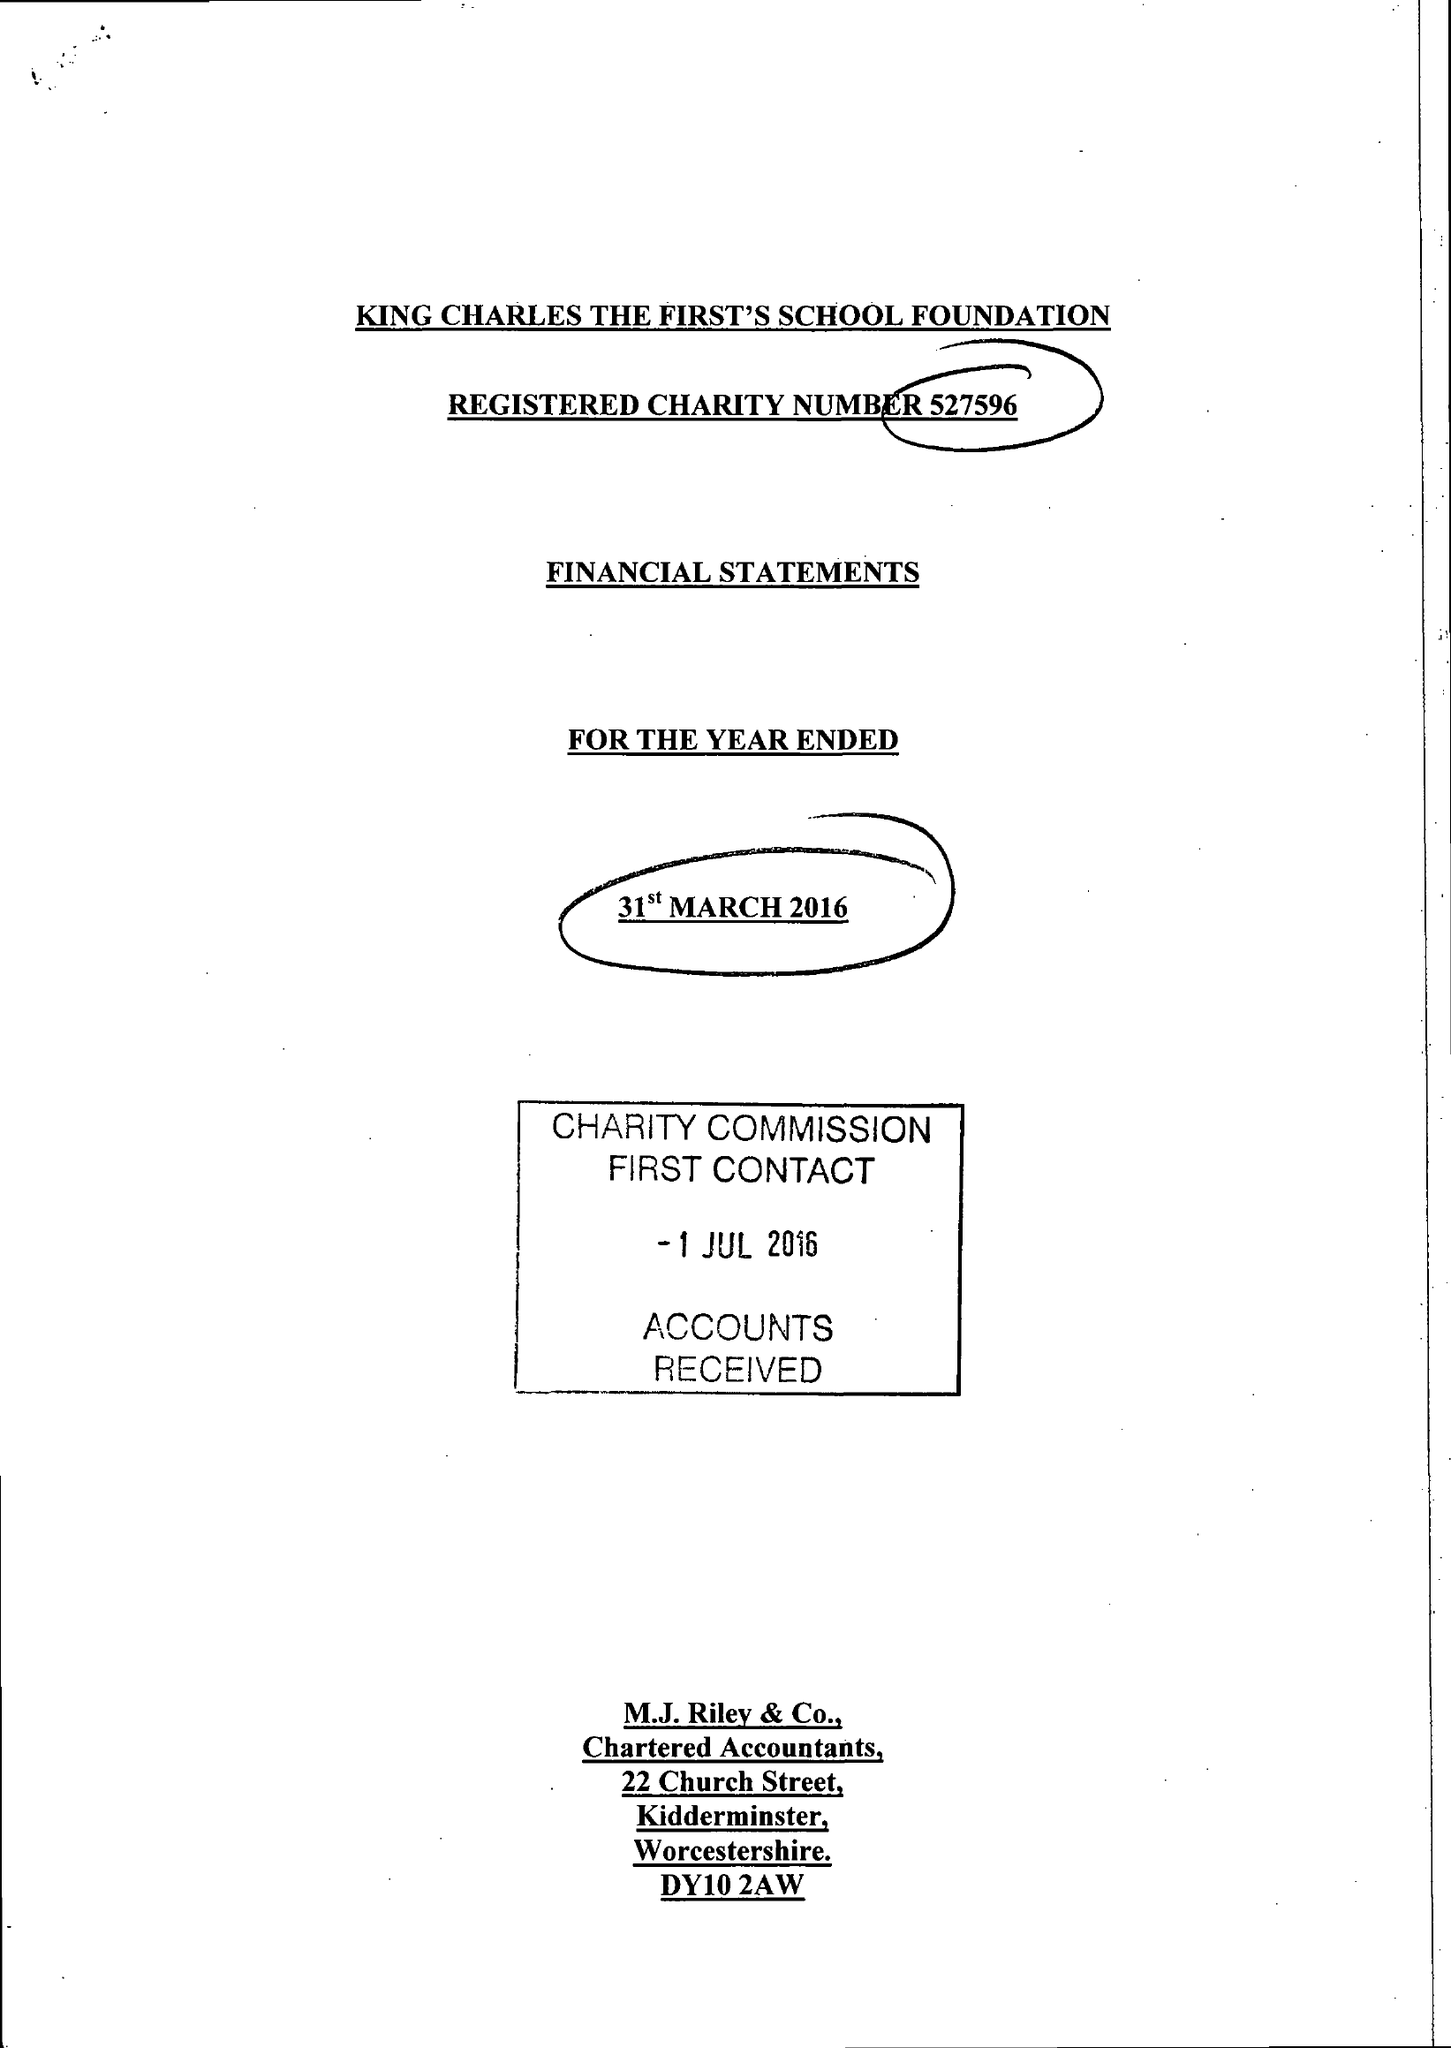What is the value for the charity_number?
Answer the question using a single word or phrase. 527596 